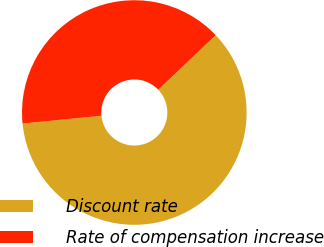Convert chart. <chart><loc_0><loc_0><loc_500><loc_500><pie_chart><fcel>Discount rate<fcel>Rate of compensation increase<nl><fcel>60.53%<fcel>39.47%<nl></chart> 